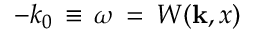Convert formula to latex. <formula><loc_0><loc_0><loc_500><loc_500>- k _ { 0 } { \, } \equiv \, \omega { \, } = { \, } W ( { k } , x )</formula> 